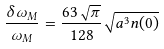<formula> <loc_0><loc_0><loc_500><loc_500>\frac { \delta \omega _ { M } } { \omega _ { M } } = \frac { 6 3 \sqrt { \pi } } { 1 2 8 } \sqrt { a ^ { 3 } n ( 0 ) }</formula> 